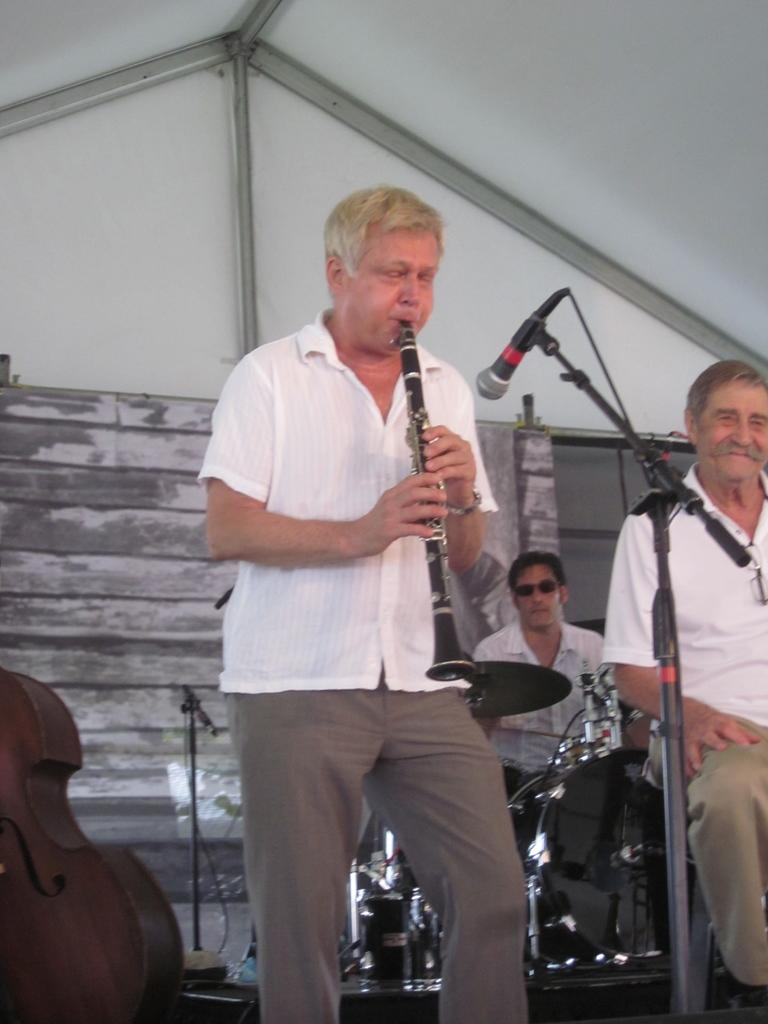How many people are in the image? There are people in the image, but the exact number is not specified. What instrument is a person holding in the image? A person is holding a clarinet in the image. What device is used for amplifying sound in the image? A microphone (mic) is present in the image. What other musical instruments can be seen in the image? Drums and a guitar are visible in the image. What can be seen in the background of the image? There is a wall in the background of the image. Is there a fan blowing on the musicians in the image? There is no mention of a fan in the image, so it cannot be determined if one is present or not. Is there a rainstorm occurring in the image? There is no indication of a rainstorm in the image, as the facts provided do not mention any weather conditions. 